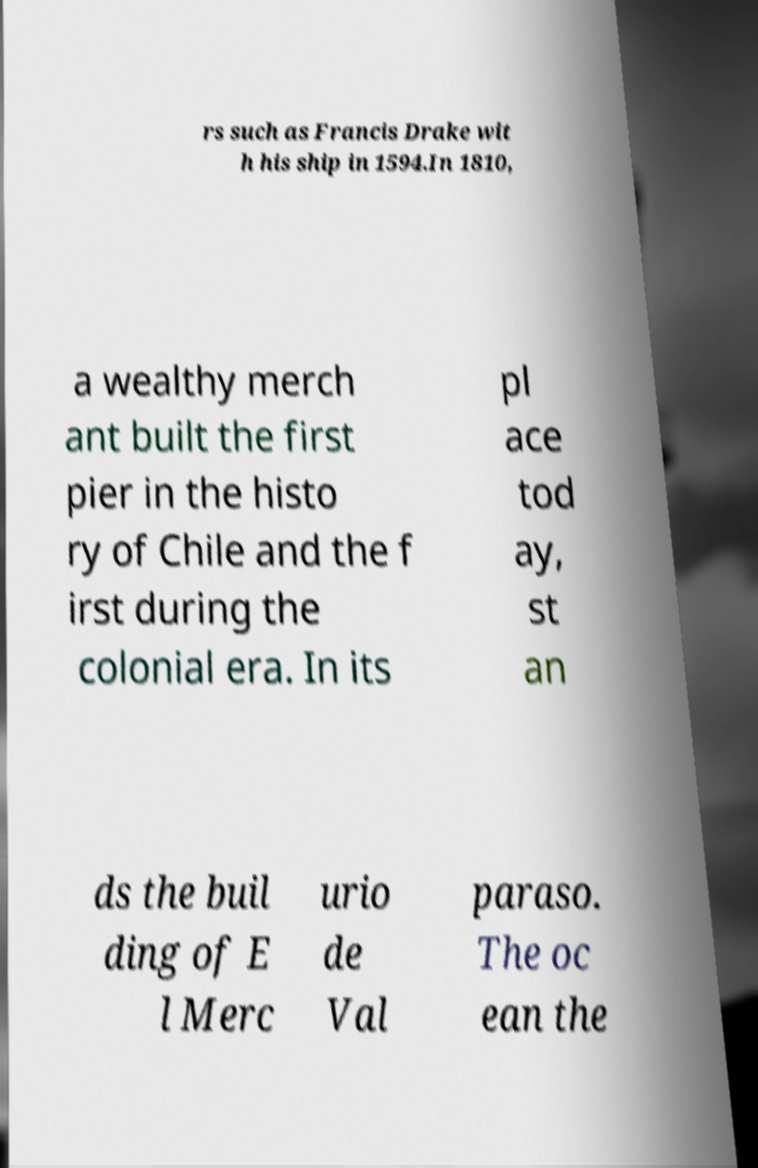What messages or text are displayed in this image? I need them in a readable, typed format. rs such as Francis Drake wit h his ship in 1594.In 1810, a wealthy merch ant built the first pier in the histo ry of Chile and the f irst during the colonial era. In its pl ace tod ay, st an ds the buil ding of E l Merc urio de Val paraso. The oc ean the 